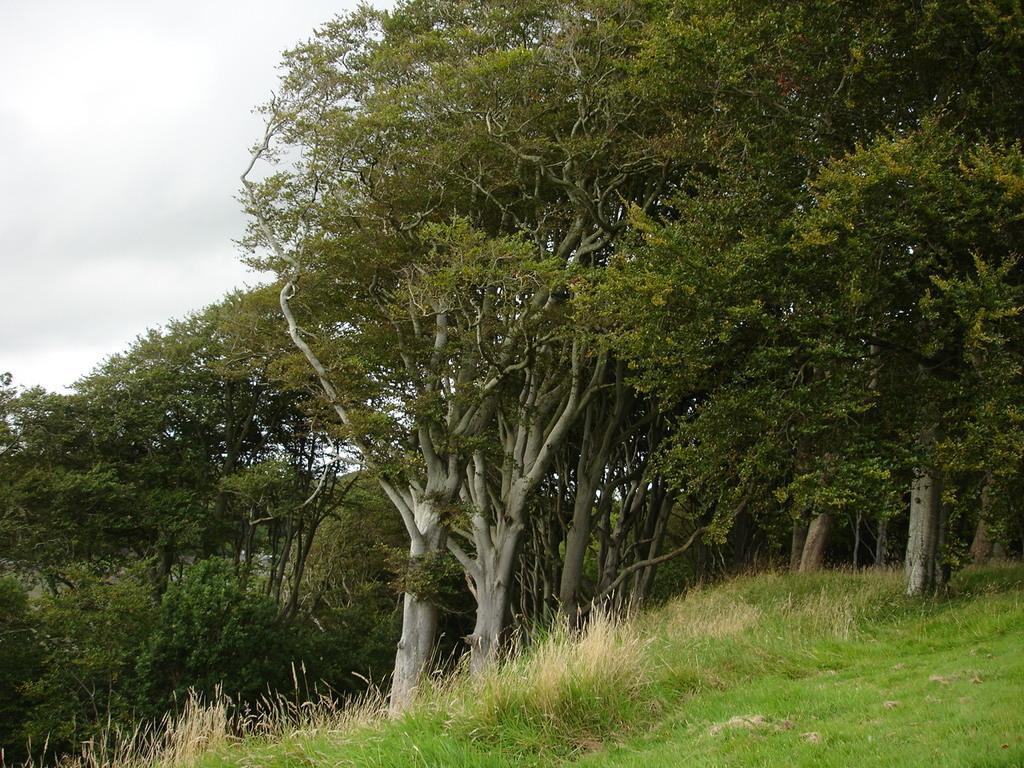Please provide a concise description of this image. In this image we can see some trees, grass, plants, and the sky. 